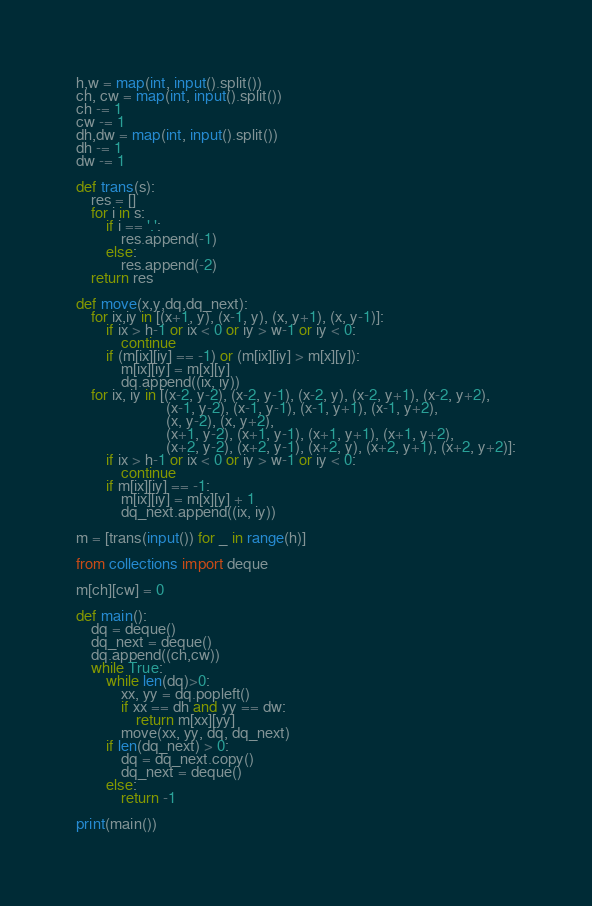<code> <loc_0><loc_0><loc_500><loc_500><_Python_>h,w = map(int, input().split())
ch, cw = map(int, input().split())
ch -= 1
cw -= 1
dh,dw = map(int, input().split())
dh -= 1
dw -= 1

def trans(s):
    res = []
    for i in s:
        if i == '.':
            res.append(-1)
        else:
            res.append(-2)
    return res

def move(x,y,dq,dq_next):
    for ix,iy in [(x+1, y), (x-1, y), (x, y+1), (x, y-1)]:
        if ix > h-1 or ix < 0 or iy > w-1 or iy < 0:
            continue
        if (m[ix][iy] == -1) or (m[ix][iy] > m[x][y]):
            m[ix][iy] = m[x][y]
            dq.append((ix, iy))
    for ix, iy in [(x-2, y-2), (x-2, y-1), (x-2, y), (x-2, y+1), (x-2, y+2),
                        (x-1, y-2), (x-1, y-1), (x-1, y+1), (x-1, y+2),
                        (x, y-2), (x, y+2),
                        (x+1, y-2), (x+1, y-1), (x+1, y+1), (x+1, y+2),
                        (x+2, y-2), (x+2, y-1), (x+2, y), (x+2, y+1), (x+2, y+2)]:
        if ix > h-1 or ix < 0 or iy > w-1 or iy < 0:
            continue
        if m[ix][iy] == -1:
            m[ix][iy] = m[x][y] + 1
            dq_next.append((ix, iy))
            
m = [trans(input()) for _ in range(h)]

from collections import deque

m[ch][cw] = 0

def main():
    dq = deque()
    dq_next = deque()
    dq.append((ch,cw))
    while True:
        while len(dq)>0:
            xx, yy = dq.popleft()
            if xx == dh and yy == dw:
                return m[xx][yy]
            move(xx, yy, dq, dq_next)
        if len(dq_next) > 0:
            dq = dq_next.copy()
            dq_next = deque()
        else:
            return -1
          
print(main())</code> 